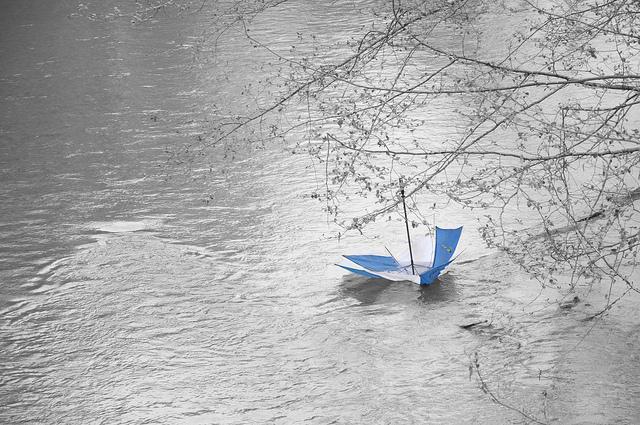How many people are wearing an orange tee shirt?
Give a very brief answer. 0. 